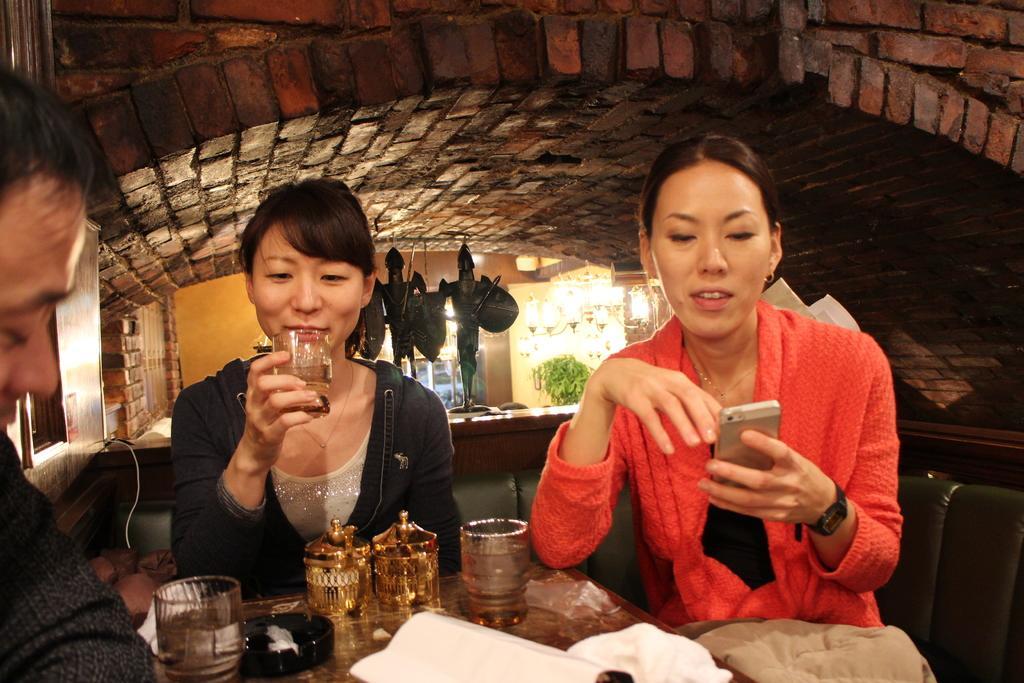In one or two sentences, can you explain what this image depicts? In this image, in the middle, we can see two women. On the right side, we can see a woman sitting on the couch and holding a mobile in her hand. In the middle of the image, we can also see another woman wearing a black color coat is holding a glass in her hand. On the left side, we can see a person sitting in front of the table, on that table a paper, cloth, glass. In the background, we can also see some sculptures, plants, lights, brick wall, glass window. At the top, we can see a roof. 